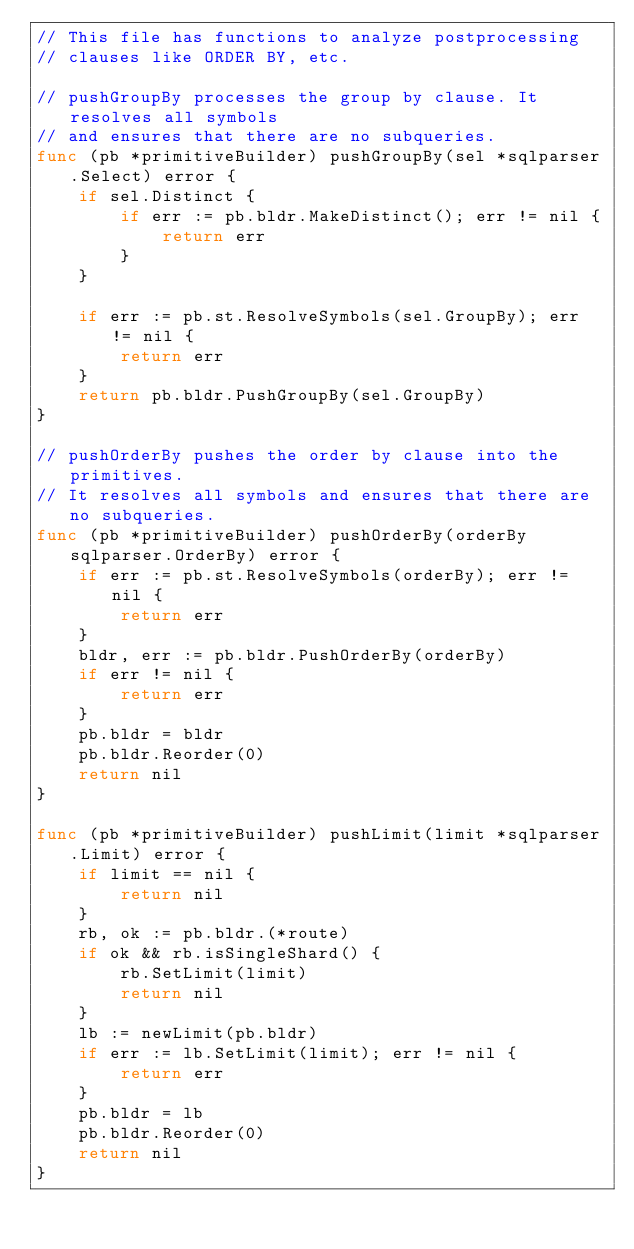<code> <loc_0><loc_0><loc_500><loc_500><_Go_>// This file has functions to analyze postprocessing
// clauses like ORDER BY, etc.

// pushGroupBy processes the group by clause. It resolves all symbols
// and ensures that there are no subqueries.
func (pb *primitiveBuilder) pushGroupBy(sel *sqlparser.Select) error {
	if sel.Distinct {
		if err := pb.bldr.MakeDistinct(); err != nil {
			return err
		}
	}

	if err := pb.st.ResolveSymbols(sel.GroupBy); err != nil {
		return err
	}
	return pb.bldr.PushGroupBy(sel.GroupBy)
}

// pushOrderBy pushes the order by clause into the primitives.
// It resolves all symbols and ensures that there are no subqueries.
func (pb *primitiveBuilder) pushOrderBy(orderBy sqlparser.OrderBy) error {
	if err := pb.st.ResolveSymbols(orderBy); err != nil {
		return err
	}
	bldr, err := pb.bldr.PushOrderBy(orderBy)
	if err != nil {
		return err
	}
	pb.bldr = bldr
	pb.bldr.Reorder(0)
	return nil
}

func (pb *primitiveBuilder) pushLimit(limit *sqlparser.Limit) error {
	if limit == nil {
		return nil
	}
	rb, ok := pb.bldr.(*route)
	if ok && rb.isSingleShard() {
		rb.SetLimit(limit)
		return nil
	}
	lb := newLimit(pb.bldr)
	if err := lb.SetLimit(limit); err != nil {
		return err
	}
	pb.bldr = lb
	pb.bldr.Reorder(0)
	return nil
}
</code> 